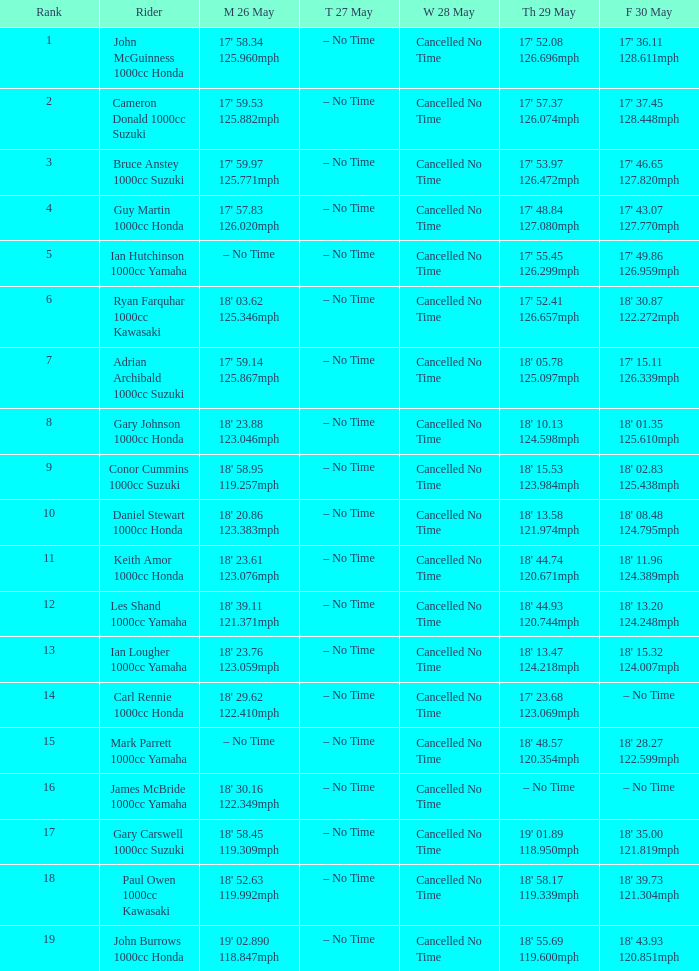What time is mon may 26 and fri may 30 is 18' 28.27 122.599mph? – No Time. 